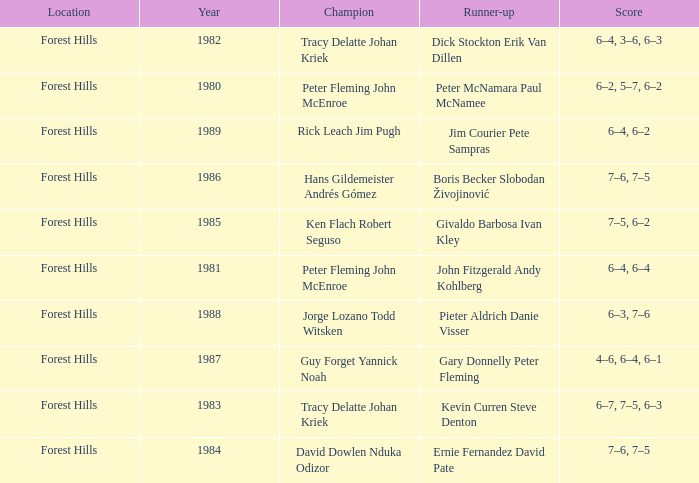Who was the runner-up in 1989? Jim Courier Pete Sampras. 